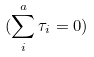Convert formula to latex. <formula><loc_0><loc_0><loc_500><loc_500>( \sum _ { i } ^ { a } \tau _ { i } = 0 )</formula> 